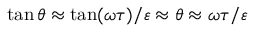<formula> <loc_0><loc_0><loc_500><loc_500>\tan \theta \approx \tan ( \omega \tau ) / \varepsilon \approx \theta \approx \omega \tau / \varepsilon</formula> 